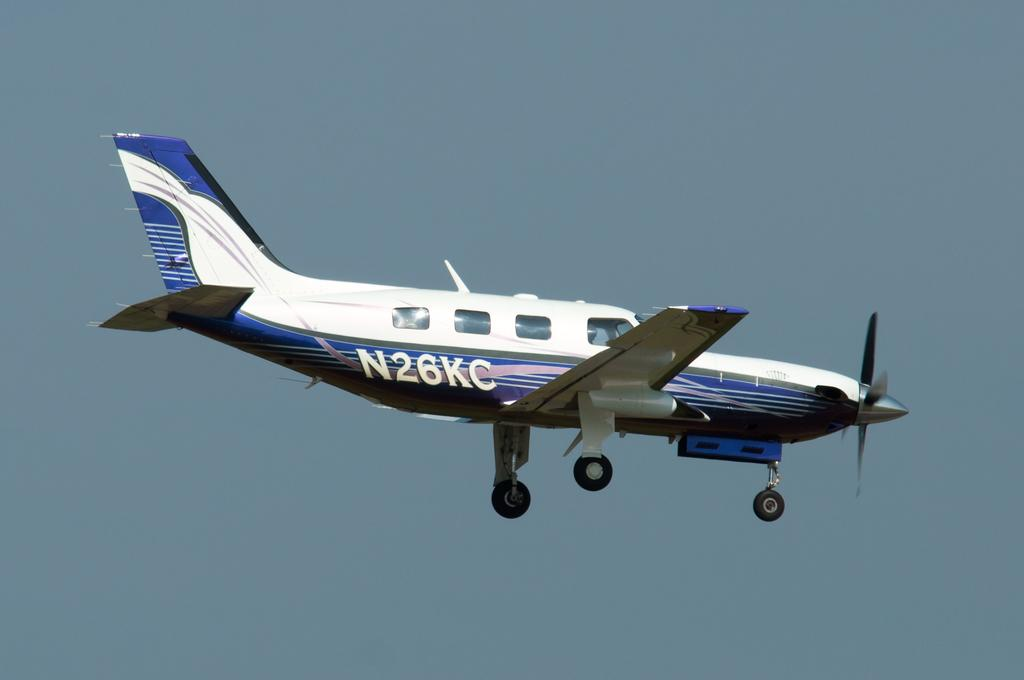<image>
Give a short and clear explanation of the subsequent image. A plane with N26KC written on its side. 